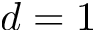<formula> <loc_0><loc_0><loc_500><loc_500>d = 1</formula> 